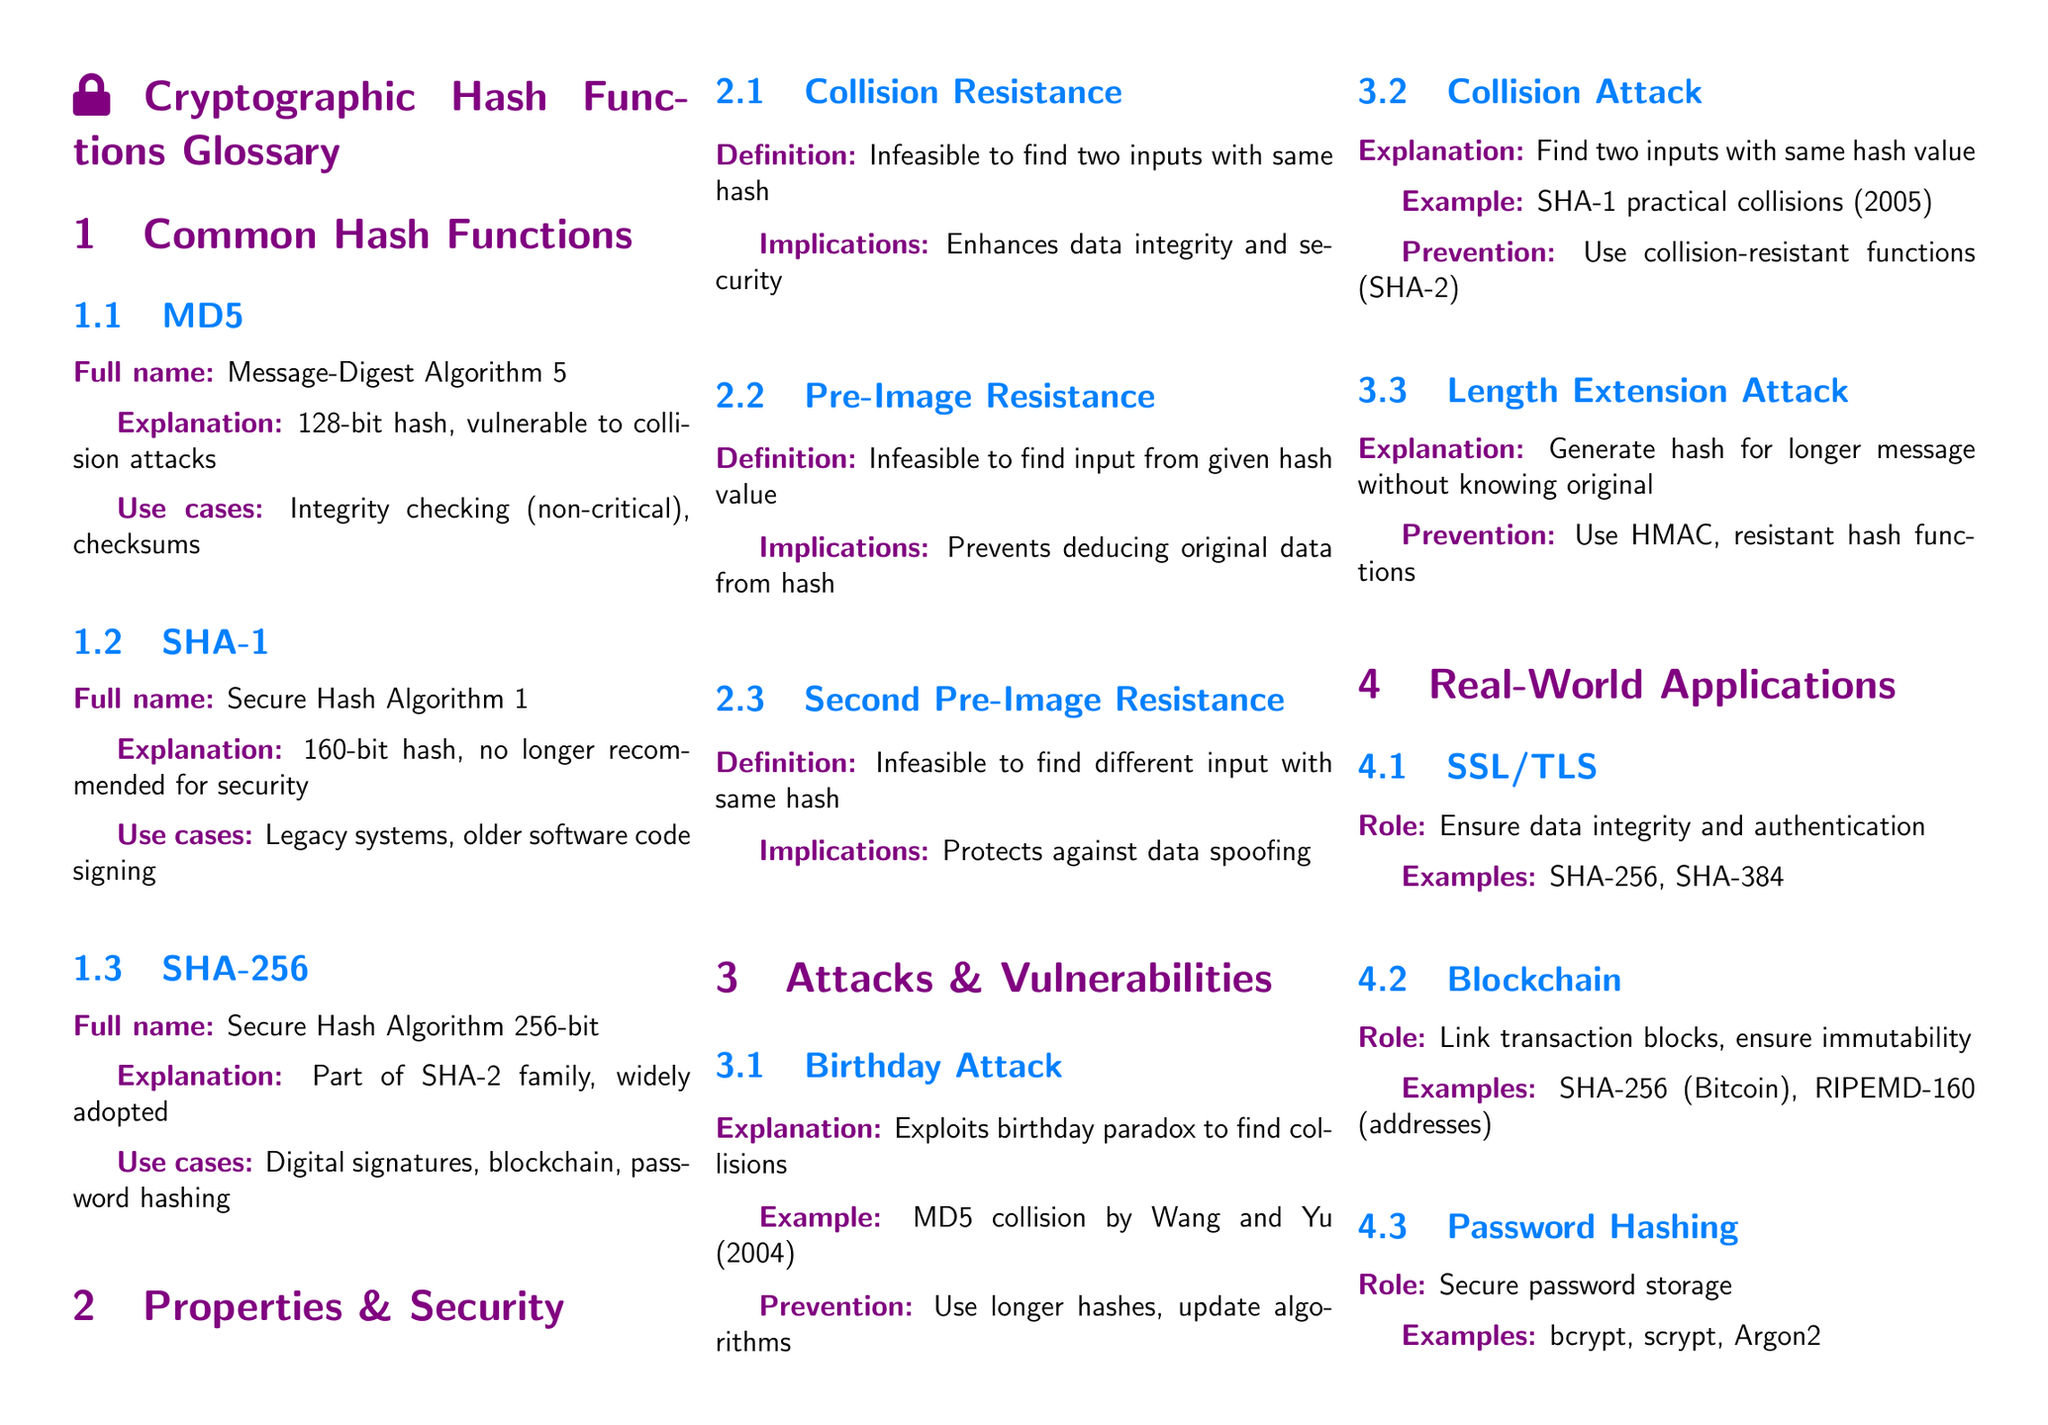What is the full name of MD5? The full name of MD5 is provided in the glossary section under Common Hash Functions.
Answer: Message-Digest Algorithm 5 Which hash function is part of the SHA-2 family? This is noted in the Common Hash Functions section, specifically regarding SHA-256.
Answer: SHA-256 What is the bit length of SHA-1? This information can be found in the SHA-1 entry under Common Hash Functions.
Answer: 160-bit Name one use case of SHA-256. The use cases for SHA-256 are listed in the glossary, detailing its applications in various scenarios.
Answer: Digital signatures What is collision resistance? This term is defined in the Properties & Security section of the document.
Answer: Infeasible to find two inputs with same hash What attack exploits the birthday paradox? This is described in the Attacks & Vulnerabilities section, specifically under Birthday Attack.
Answer: Birthday Attack What role do hash functions play in blockchain? The role of hash functions in blockchain is explained in the Real-World Applications section.
Answer: Link transaction blocks, ensure immutability What is one example of a password hashing scheme? This can be found in the Real-World Applications section, where various schemes are listed.
Answer: bcrypt What is a focus of future hash function research? This is mentioned in the Advanced Topics section regarding future research directions.
Answer: Quantum-resistant hash functions 